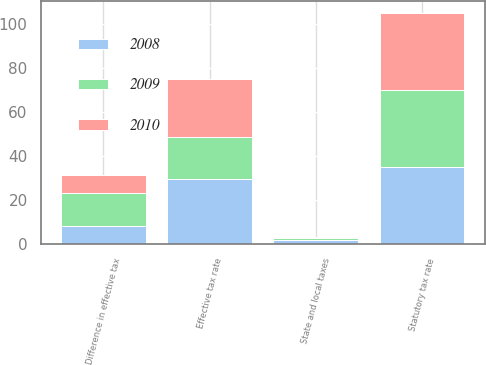Convert chart to OTSL. <chart><loc_0><loc_0><loc_500><loc_500><stacked_bar_chart><ecel><fcel>Statutory tax rate<fcel>Difference in effective tax<fcel>State and local taxes<fcel>Effective tax rate<nl><fcel>2010<fcel>35<fcel>8.1<fcel>0.6<fcel>26.7<nl><fcel>2008<fcel>35<fcel>8<fcel>1.7<fcel>29.3<nl><fcel>2009<fcel>35<fcel>15<fcel>0.7<fcel>19.1<nl></chart> 